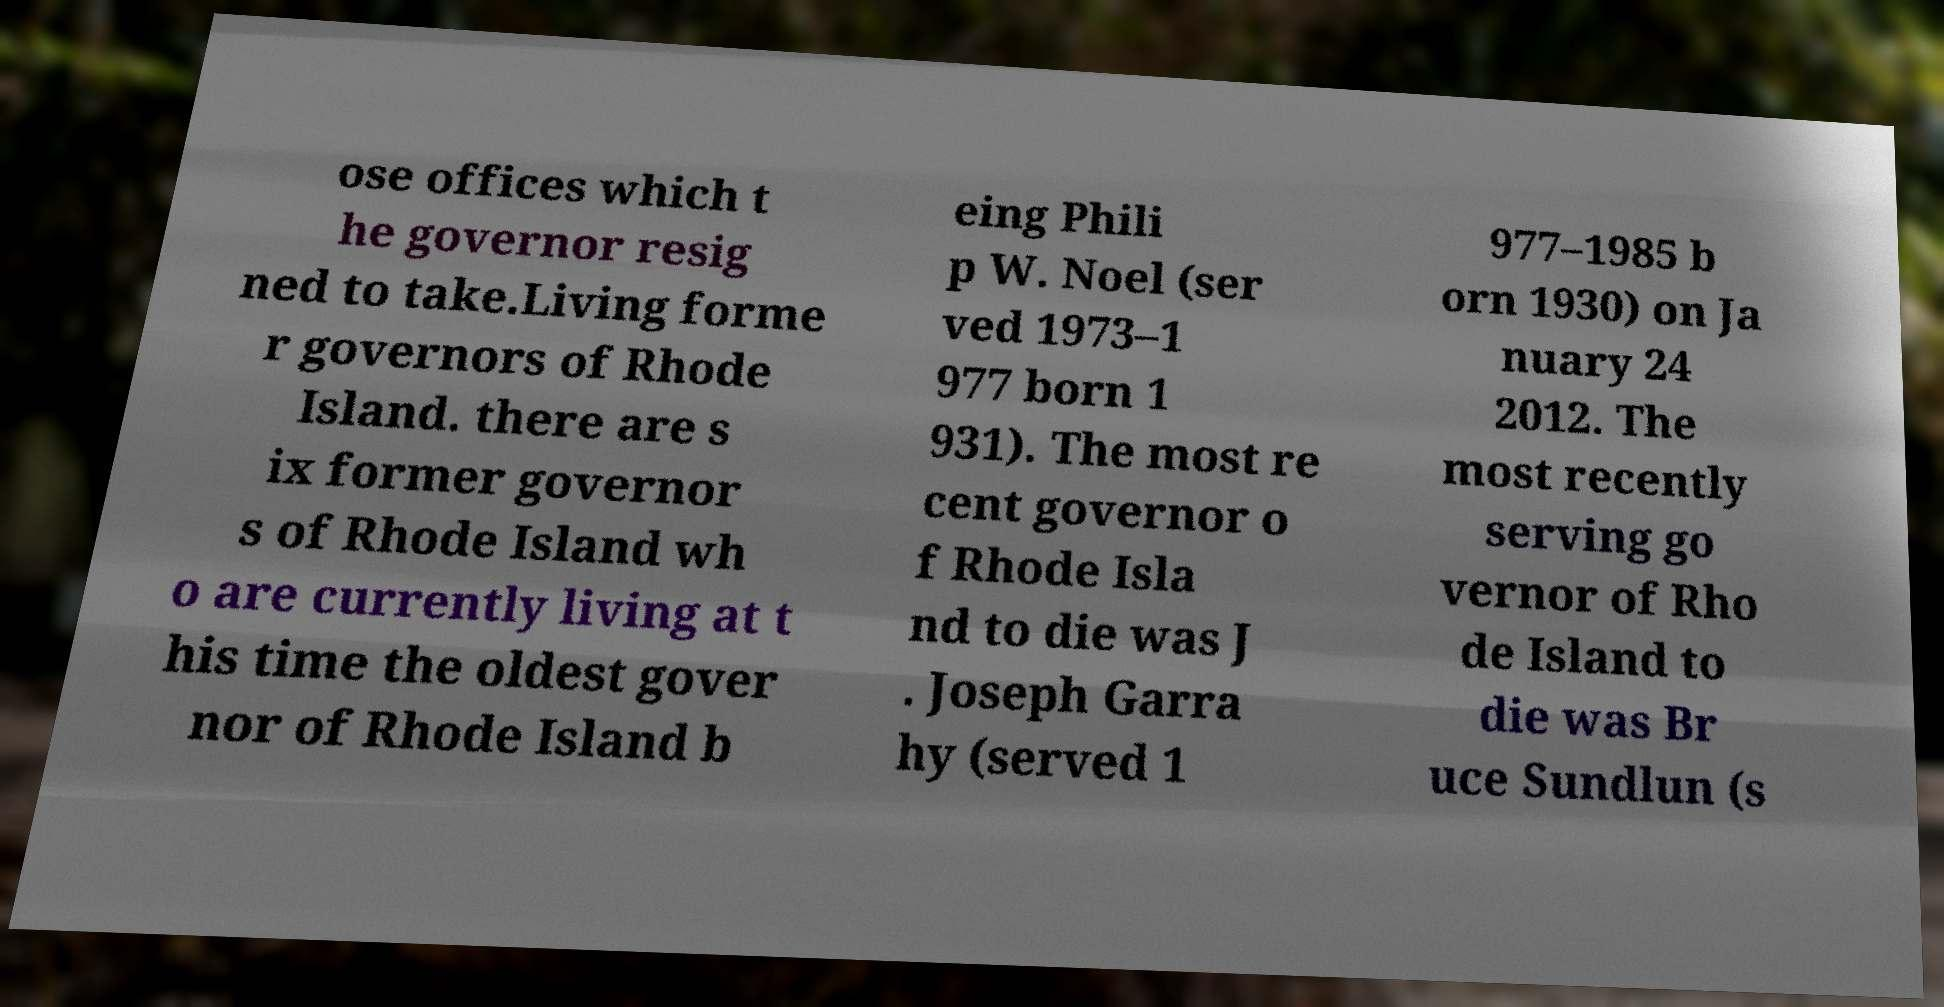Could you assist in decoding the text presented in this image and type it out clearly? ose offices which t he governor resig ned to take.Living forme r governors of Rhode Island. there are s ix former governor s of Rhode Island wh o are currently living at t his time the oldest gover nor of Rhode Island b eing Phili p W. Noel (ser ved 1973–1 977 born 1 931). The most re cent governor o f Rhode Isla nd to die was J . Joseph Garra hy (served 1 977–1985 b orn 1930) on Ja nuary 24 2012. The most recently serving go vernor of Rho de Island to die was Br uce Sundlun (s 